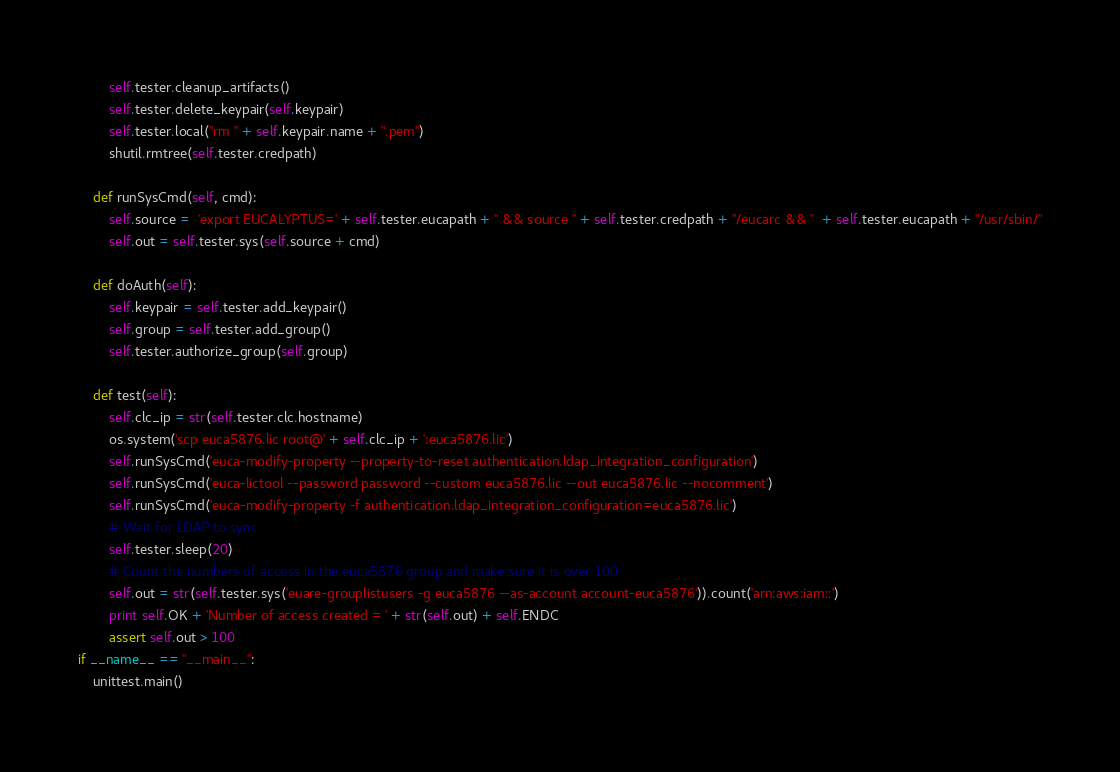<code> <loc_0><loc_0><loc_500><loc_500><_Python_>        self.tester.cleanup_artifacts()
        self.tester.delete_keypair(self.keypair)
        self.tester.local("rm " + self.keypair.name + ".pem")
        shutil.rmtree(self.tester.credpath)

    def runSysCmd(self, cmd):
        self.source =  'export EUCALYPTUS=' + self.tester.eucapath + " && source " + self.tester.credpath + "/eucarc && "  + self.tester.eucapath + "/usr/sbin/"
        self.out = self.tester.sys(self.source + cmd)

    def doAuth(self):
        self.keypair = self.tester.add_keypair()
        self.group = self.tester.add_group()
        self.tester.authorize_group(self.group)

    def test(self):
        self.clc_ip = str(self.tester.clc.hostname)
        os.system('scp euca5876.lic root@' + self.clc_ip + ':euca5876.lic')
        self.runSysCmd('euca-modify-property --property-to-reset authentication.ldap_integration_configuration')
        self.runSysCmd('euca-lictool --password password --custom euca5876.lic --out euca5876.lic --nocomment')
        self.runSysCmd('euca-modify-property -f authentication.ldap_integration_configuration=euca5876.lic')
        # Wait for LDAP to sync
        self.tester.sleep(20)
        # Count the numbers of access in the euca5876 group and make sure it is over 100
        self.out = str(self.tester.sys('euare-grouplistusers -g euca5876 --as-account account-euca5876')).count('arn:aws:iam::')
        print self.OK + 'Number of access created = ' + str(self.out) + self.ENDC
        assert self.out > 100
if __name__ == "__main__":
    unittest.main()</code> 